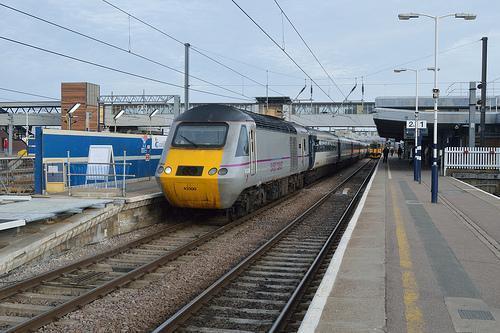How many people are waiting for the train that is approaching in the distance?
Give a very brief answer. 3. How many trains are in the picture total?
Give a very brief answer. 2. How many tracks are there?
Give a very brief answer. 2. 